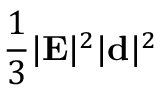Convert formula to latex. <formula><loc_0><loc_0><loc_500><loc_500>\frac { 1 } { 3 } | { E } | ^ { 2 } | { d } | ^ { 2 }</formula> 